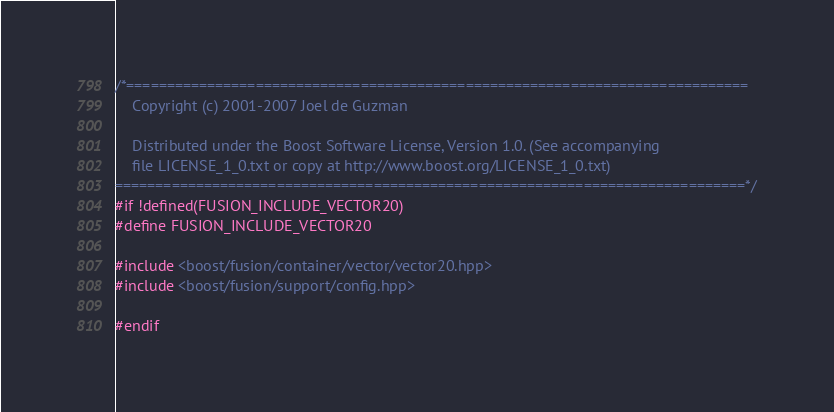<code> <loc_0><loc_0><loc_500><loc_500><_C++_>/*=============================================================================
    Copyright (c) 2001-2007 Joel de Guzman

    Distributed under the Boost Software License, Version 1.0. (See accompanying
    file LICENSE_1_0.txt or copy at http://www.boost.org/LICENSE_1_0.txt)
==============================================================================*/
#if !defined(FUSION_INCLUDE_VECTOR20)
#define FUSION_INCLUDE_VECTOR20

#include <boost/fusion/container/vector/vector20.hpp>
#include <boost/fusion/support/config.hpp>

#endif
</code> 